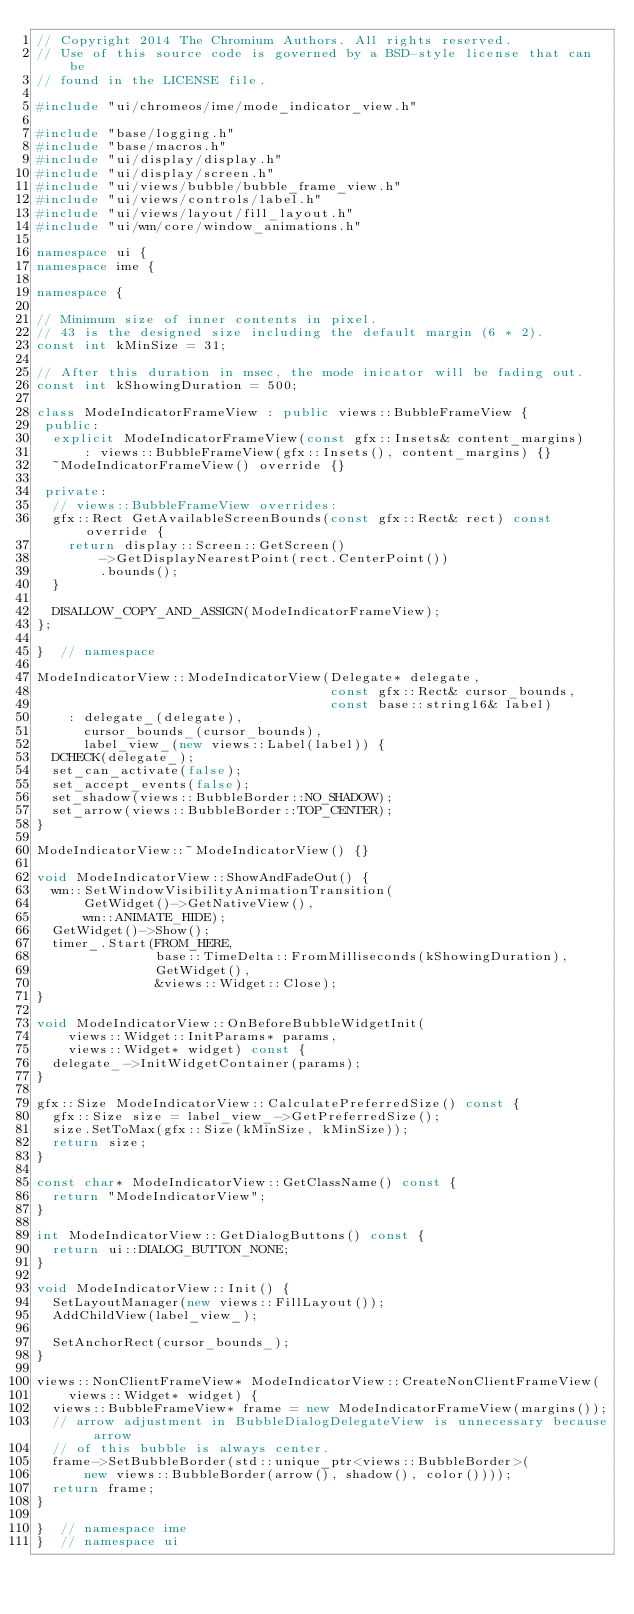<code> <loc_0><loc_0><loc_500><loc_500><_C++_>// Copyright 2014 The Chromium Authors. All rights reserved.
// Use of this source code is governed by a BSD-style license that can be
// found in the LICENSE file.

#include "ui/chromeos/ime/mode_indicator_view.h"

#include "base/logging.h"
#include "base/macros.h"
#include "ui/display/display.h"
#include "ui/display/screen.h"
#include "ui/views/bubble/bubble_frame_view.h"
#include "ui/views/controls/label.h"
#include "ui/views/layout/fill_layout.h"
#include "ui/wm/core/window_animations.h"

namespace ui {
namespace ime {

namespace {

// Minimum size of inner contents in pixel.
// 43 is the designed size including the default margin (6 * 2).
const int kMinSize = 31;

// After this duration in msec, the mode inicator will be fading out.
const int kShowingDuration = 500;

class ModeIndicatorFrameView : public views::BubbleFrameView {
 public:
  explicit ModeIndicatorFrameView(const gfx::Insets& content_margins)
      : views::BubbleFrameView(gfx::Insets(), content_margins) {}
  ~ModeIndicatorFrameView() override {}

 private:
  // views::BubbleFrameView overrides:
  gfx::Rect GetAvailableScreenBounds(const gfx::Rect& rect) const override {
    return display::Screen::GetScreen()
        ->GetDisplayNearestPoint(rect.CenterPoint())
        .bounds();
  }

  DISALLOW_COPY_AND_ASSIGN(ModeIndicatorFrameView);
};

}  // namespace

ModeIndicatorView::ModeIndicatorView(Delegate* delegate,
                                     const gfx::Rect& cursor_bounds,
                                     const base::string16& label)
    : delegate_(delegate),
      cursor_bounds_(cursor_bounds),
      label_view_(new views::Label(label)) {
  DCHECK(delegate_);
  set_can_activate(false);
  set_accept_events(false);
  set_shadow(views::BubbleBorder::NO_SHADOW);
  set_arrow(views::BubbleBorder::TOP_CENTER);
}

ModeIndicatorView::~ModeIndicatorView() {}

void ModeIndicatorView::ShowAndFadeOut() {
  wm::SetWindowVisibilityAnimationTransition(
      GetWidget()->GetNativeView(),
      wm::ANIMATE_HIDE);
  GetWidget()->Show();
  timer_.Start(FROM_HERE,
               base::TimeDelta::FromMilliseconds(kShowingDuration),
               GetWidget(),
               &views::Widget::Close);
}

void ModeIndicatorView::OnBeforeBubbleWidgetInit(
    views::Widget::InitParams* params,
    views::Widget* widget) const {
  delegate_->InitWidgetContainer(params);
}

gfx::Size ModeIndicatorView::CalculatePreferredSize() const {
  gfx::Size size = label_view_->GetPreferredSize();
  size.SetToMax(gfx::Size(kMinSize, kMinSize));
  return size;
}

const char* ModeIndicatorView::GetClassName() const {
  return "ModeIndicatorView";
}

int ModeIndicatorView::GetDialogButtons() const {
  return ui::DIALOG_BUTTON_NONE;
}

void ModeIndicatorView::Init() {
  SetLayoutManager(new views::FillLayout());
  AddChildView(label_view_);

  SetAnchorRect(cursor_bounds_);
}

views::NonClientFrameView* ModeIndicatorView::CreateNonClientFrameView(
    views::Widget* widget) {
  views::BubbleFrameView* frame = new ModeIndicatorFrameView(margins());
  // arrow adjustment in BubbleDialogDelegateView is unnecessary because arrow
  // of this bubble is always center.
  frame->SetBubbleBorder(std::unique_ptr<views::BubbleBorder>(
      new views::BubbleBorder(arrow(), shadow(), color())));
  return frame;
}

}  // namespace ime
}  // namespace ui
</code> 